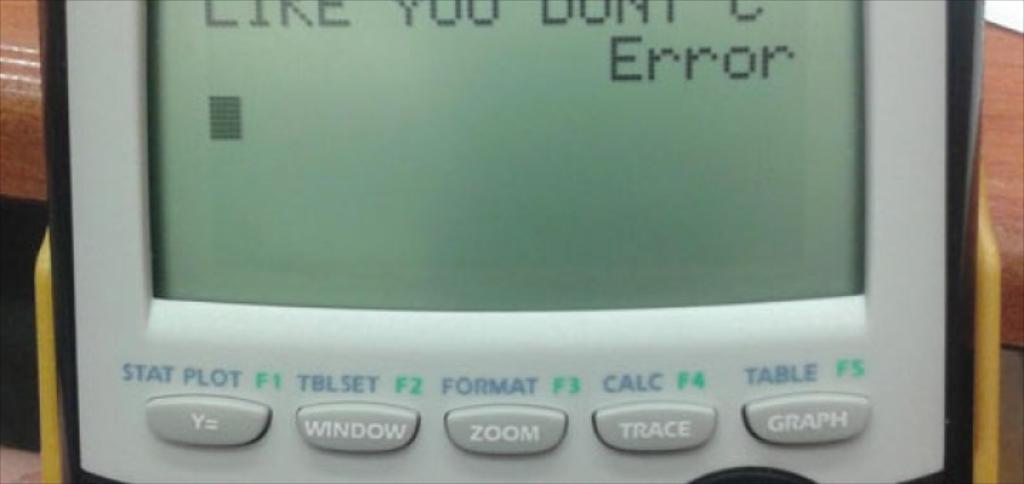<image>
Describe the image concisely. A calculator with an error message appearing on the screen. 